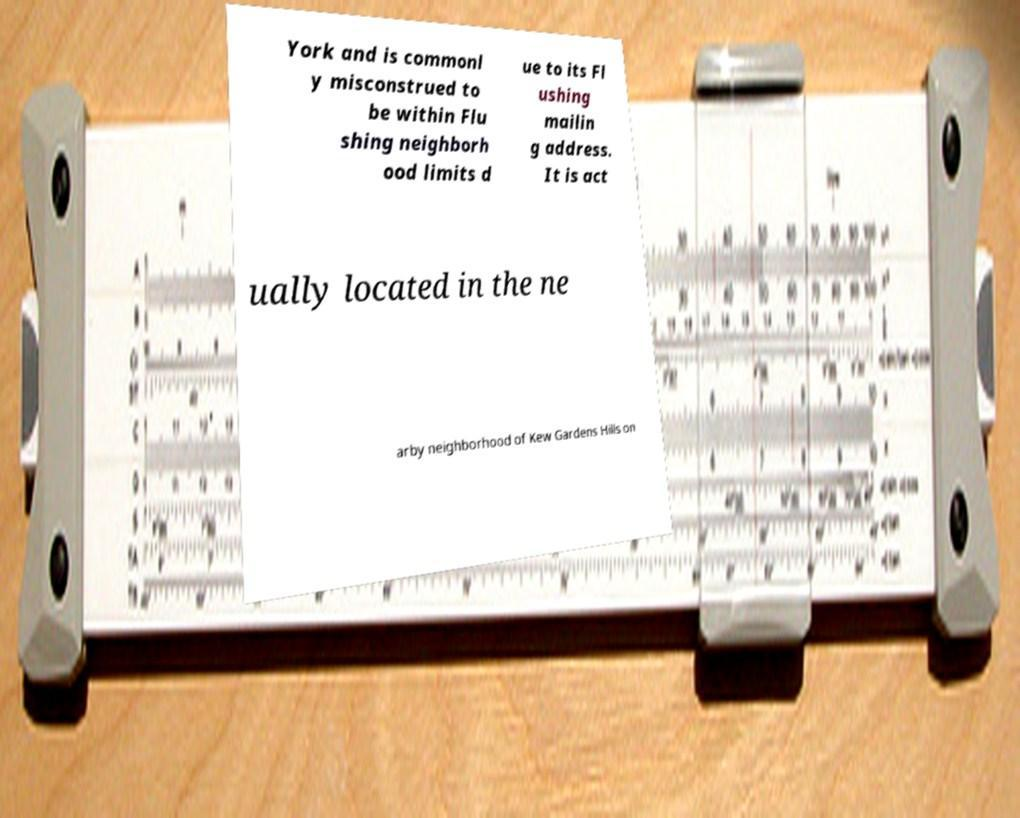There's text embedded in this image that I need extracted. Can you transcribe it verbatim? York and is commonl y misconstrued to be within Flu shing neighborh ood limits d ue to its Fl ushing mailin g address. It is act ually located in the ne arby neighborhood of Kew Gardens Hills on 